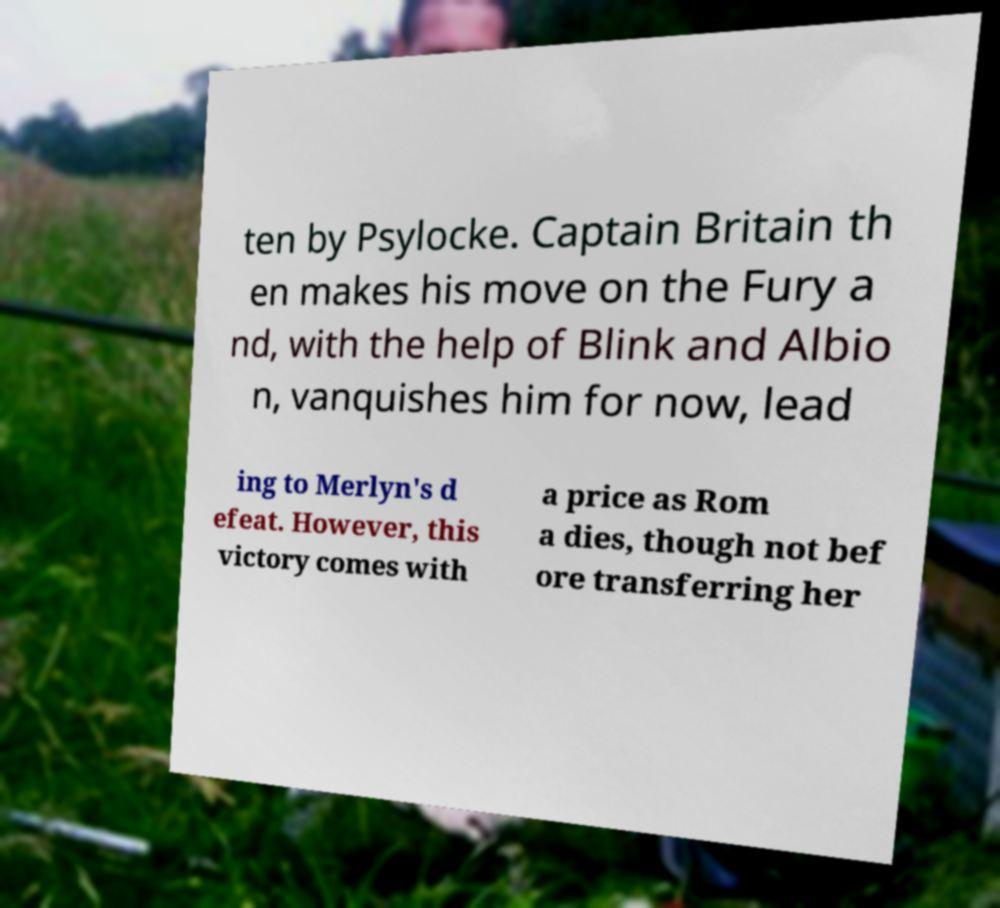Could you assist in decoding the text presented in this image and type it out clearly? ten by Psylocke. Captain Britain th en makes his move on the Fury a nd, with the help of Blink and Albio n, vanquishes him for now, lead ing to Merlyn's d efeat. However, this victory comes with a price as Rom a dies, though not bef ore transferring her 